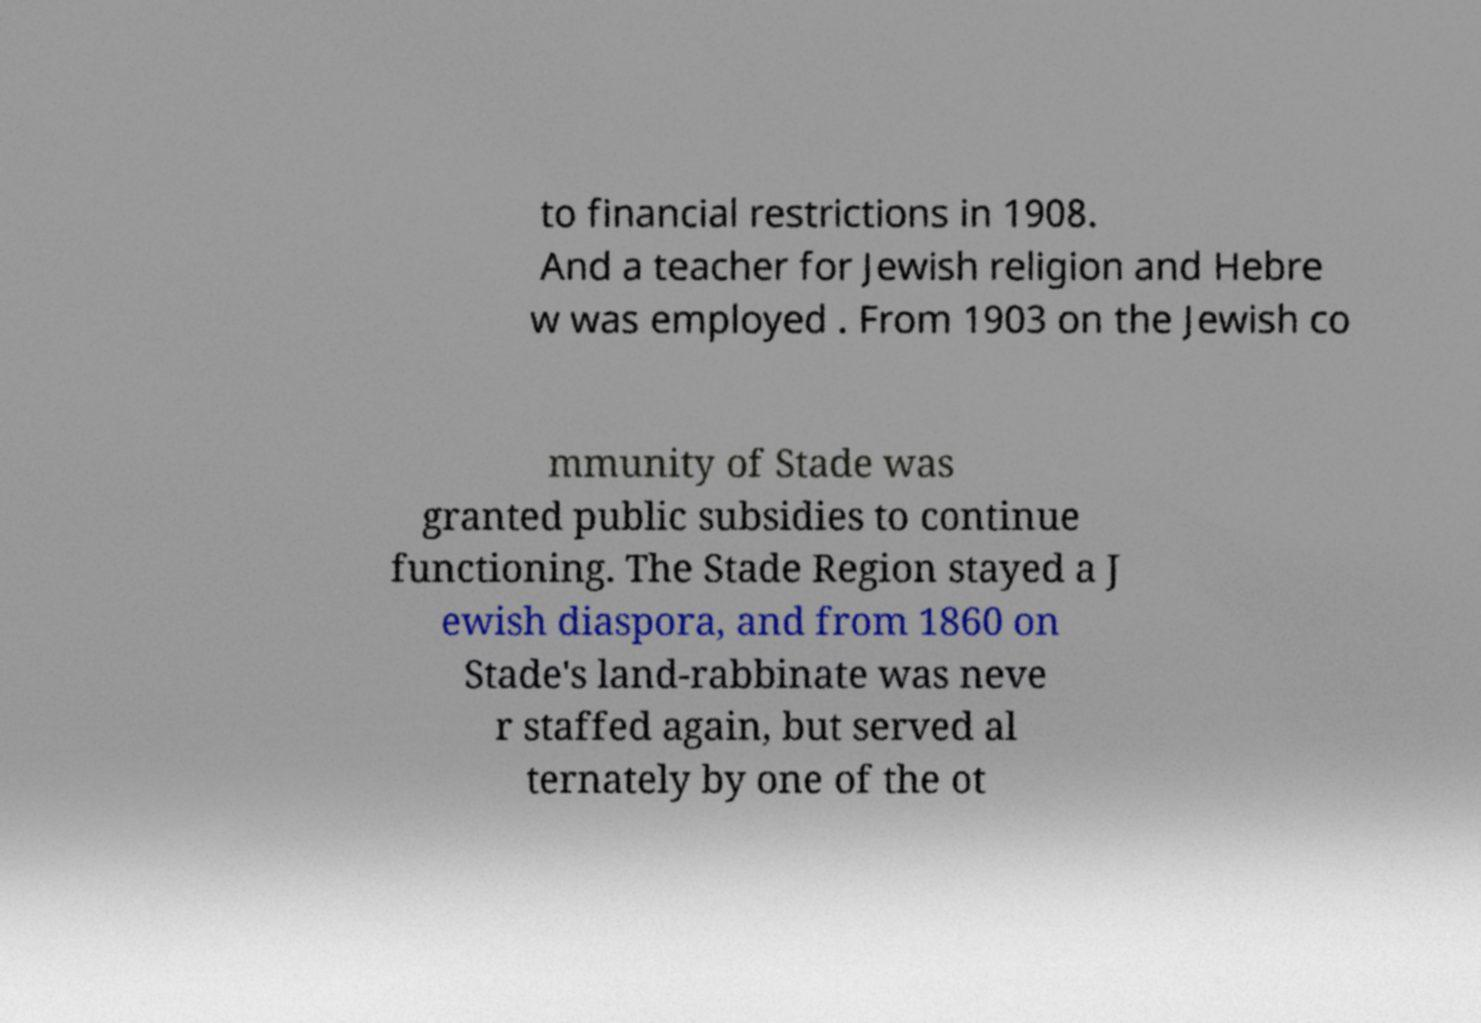Can you read and provide the text displayed in the image?This photo seems to have some interesting text. Can you extract and type it out for me? to financial restrictions in 1908. And a teacher for Jewish religion and Hebre w was employed . From 1903 on the Jewish co mmunity of Stade was granted public subsidies to continue functioning. The Stade Region stayed a J ewish diaspora, and from 1860 on Stade's land-rabbinate was neve r staffed again, but served al ternately by one of the ot 